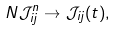<formula> <loc_0><loc_0><loc_500><loc_500>N \mathcal { J } _ { i j } ^ { n } \to \mathcal { J } _ { i j } ( t ) ,</formula> 